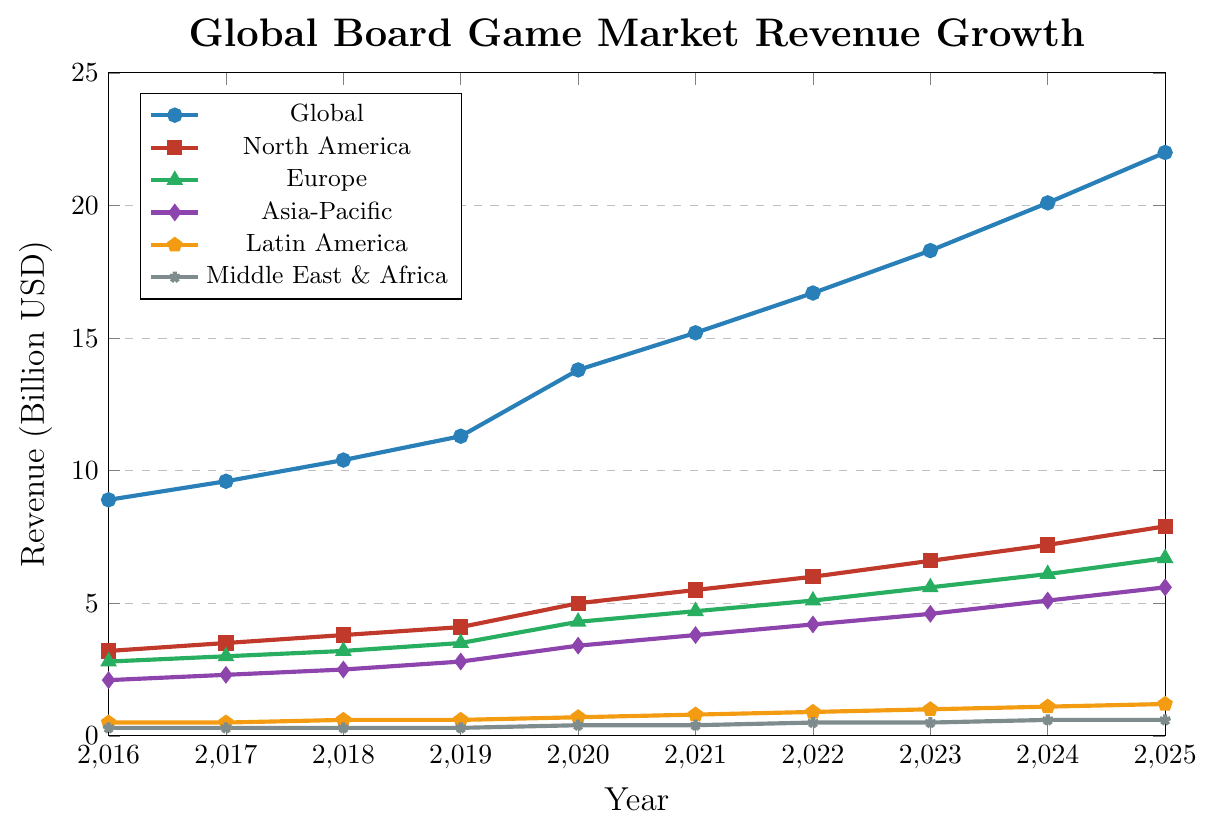Which region had the highest revenue in 2020? To find the region with the highest revenue in 2020, we compare the revenue values for each region in 2020. North America had $5.0 billion, Europe $4.3 billion, Asia-Pacific $3.4 billion, Latin America $0.7 billion, and Middle East & Africa $0.4 billion. The highest value is $5.0 billion in North America.
Answer: North America What is the difference in revenue between Europe and Asia-Pacific in 2019? In 2019, the revenue for Europe was $3.5 billion and for Asia-Pacific was $2.8 billion. The difference is calculated by subtracting the two values: $3.5 billion - $2.8 billion = $0.7 billion.
Answer: $0.7 billion Which region had a more rapid increase in revenue between 2017 and 2018, North America or Latin America? To determine the more rapid increase, calculate the revenue difference between 2017 and 2018 for both regions. North America's revenue increased from $3.5 billion to $3.8 billion, an increase of $0.3 billion. Latin America's revenue increased from $0.5 billion to $0.6 billion, an increase of $0.1 billion. North America had a more rapid increase.
Answer: North America How much total revenue did the global board game market generate from 2020 to 2022 inclusive? First, sum the global revenue for the years 2020, 2021, and 2022. The values are $13.8 billion, $15.2 billion, and $16.7 billion. Total revenue = $13.8 billion + $15.2 billion + $16.7 billion = $45.7 billion.
Answer: $45.7 billion What fraction of the global market revenue did Asia-Pacific contribute in 2023? In 2023, the global revenue was $18.3 billion, and Asia-Pacific's revenue was $4.6 billion. The fraction is calculated by dividing the Asia-Pacific revenue by the global revenue: $4.6 billion / $18.3 billion ≈ 0.251.
Answer: roughly 0.251 Between 2016 and 2025, in which year did Europe see the highest single-year increase in revenue? To find the highest single-year increase for Europe, calculate the year-on-year revenue changes for all years. The changes are: 2017 – $0.2 billion; 2018 – $0.2 billion; 2019 – $0.3 billion; 2020 – $0.8 billion; 2021 – $0.4 billion; 2022 – $0.4 billion; 2023 – $0.5 billion; 2024 – $0.5 billion; 2025 – $0.6 billion. The highest single-year increase was in 2020, with $0.8 billion.
Answer: 2020 What is the average annual revenue growth for Latin America from 2016 to 2025? First, calculate the annual revenue growth for each year from 2016 to 2025 and then find the average of these growth values. The values are: 2017 – $0 billion; 2018 – $0.1 billion; 2019 – $0 billion; 2020 – $0.1 billion; 2021 – $0.1 billion; 2022 – $0.1 billion; 2023 – $0.1 billion; 2024 – $0.1 billion; 2025 – $0.1 billion. Sum = $0.7 billion. Average = $0.7 billion / 9 = $0.078 billion.
Answer: $0.078 billion Was there any year where the revenue for Middle East & Africa did not change compared to the previous year? Reviewing the data for the Middle East & Africa, we see the revenue remains the same at $0.3 billion from 2016 to 2019 and at $0.5 billion from 2022 to 2023.
Answer: Yes, between 2016 and 2019 and between 2022 and 2023 How does the growth rate from 2023 to 2024 for the global market compare to the growth rate for Asia-Pacific in the same period? To find the growth rates, calculate the percentage increases from 2023 to 2024. For the global market, the increase is $20.1 billion - $18.3 billion = $1.8 billion. Growth rate = $1.8 billion / $18.3 billion ≈ 0.098 = 9.8%. For Asia-Pacific, the increase is $5.1 billion - $4.6 billion = $0.5 billion. Growth rate = $0.5 billion / $4.6 billion ≈ 0.109 = 10.9%. Asia-Pacific has a higher growth rate.
Answer: Asia-Pacific What is the overall increase in global revenue from 2016 to 2025? To find the overall increase, subtract the 2016 revenue from the 2025 revenue. The values are $22.0 billion in 2025 and $8.9 billion in 2016. The overall increase is $22.0 billion - $8.9 billion = $13.1 billion.
Answer: $13.1 billion 